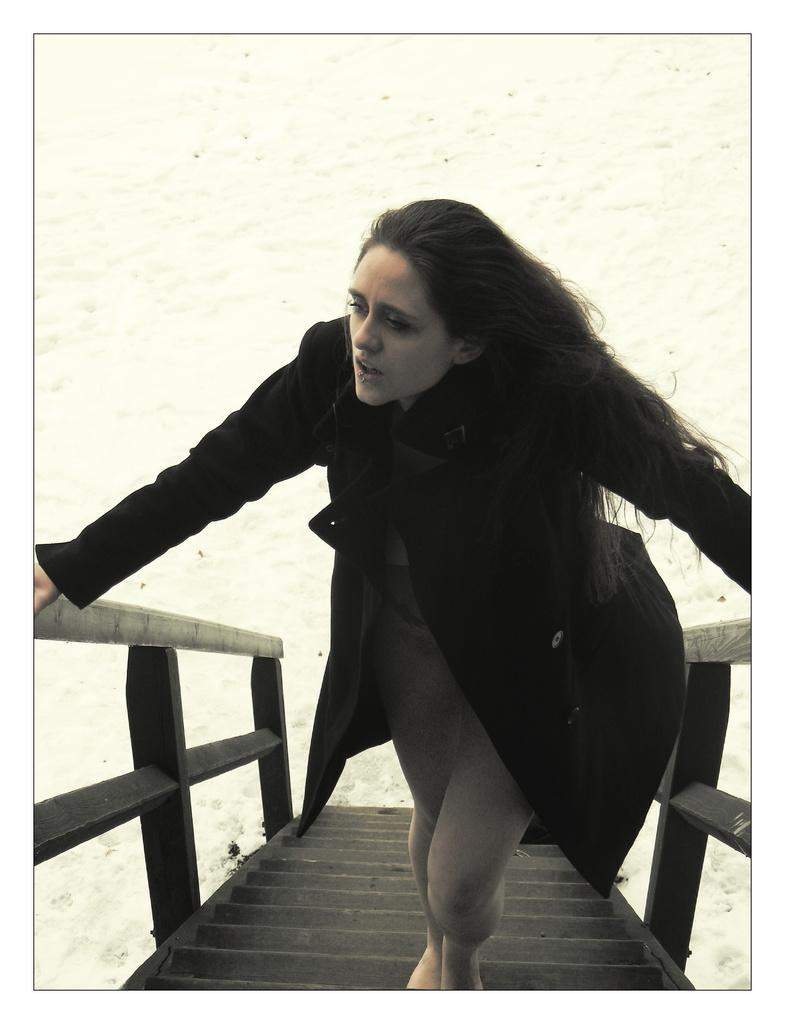Who is the main subject in the image? There is a woman in the image. What is the woman standing on? The woman is standing on wooden stairs. Who is the woman looking at? The woman is looking at someone. What force is being applied to the shelf in the image? There is no shelf present in the image, so no force is being applied to a shelf. 